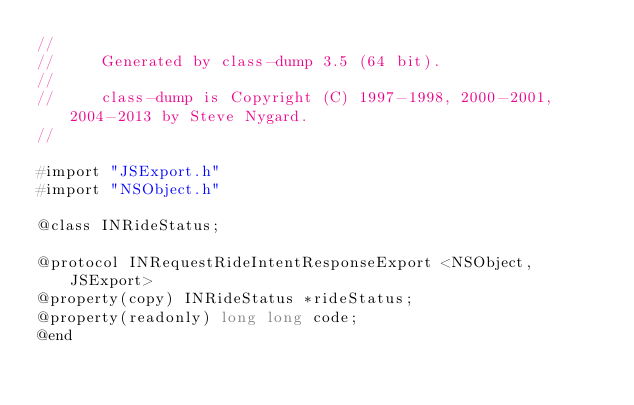Convert code to text. <code><loc_0><loc_0><loc_500><loc_500><_C_>//
//     Generated by class-dump 3.5 (64 bit).
//
//     class-dump is Copyright (C) 1997-1998, 2000-2001, 2004-2013 by Steve Nygard.
//

#import "JSExport.h"
#import "NSObject.h"

@class INRideStatus;

@protocol INRequestRideIntentResponseExport <NSObject, JSExport>
@property(copy) INRideStatus *rideStatus;
@property(readonly) long long code;
@end

</code> 